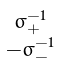Convert formula to latex. <formula><loc_0><loc_0><loc_500><loc_500>\begin{smallmatrix} \sigma _ { + } ^ { - 1 } \\ - \sigma _ { - } ^ { - 1 } \end{smallmatrix}</formula> 